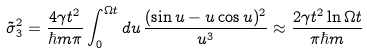<formula> <loc_0><loc_0><loc_500><loc_500>\tilde { \sigma } _ { 3 } ^ { 2 } = \frac { 4 \gamma t ^ { 2 } } { \hbar { m } \pi } \int _ { 0 } ^ { \Omega t } d u \, \frac { ( \sin u - u \cos u ) ^ { 2 } } { u ^ { 3 } } \approx \frac { 2 \gamma t ^ { 2 } \ln \Omega t } { \pi \hbar { m } }</formula> 